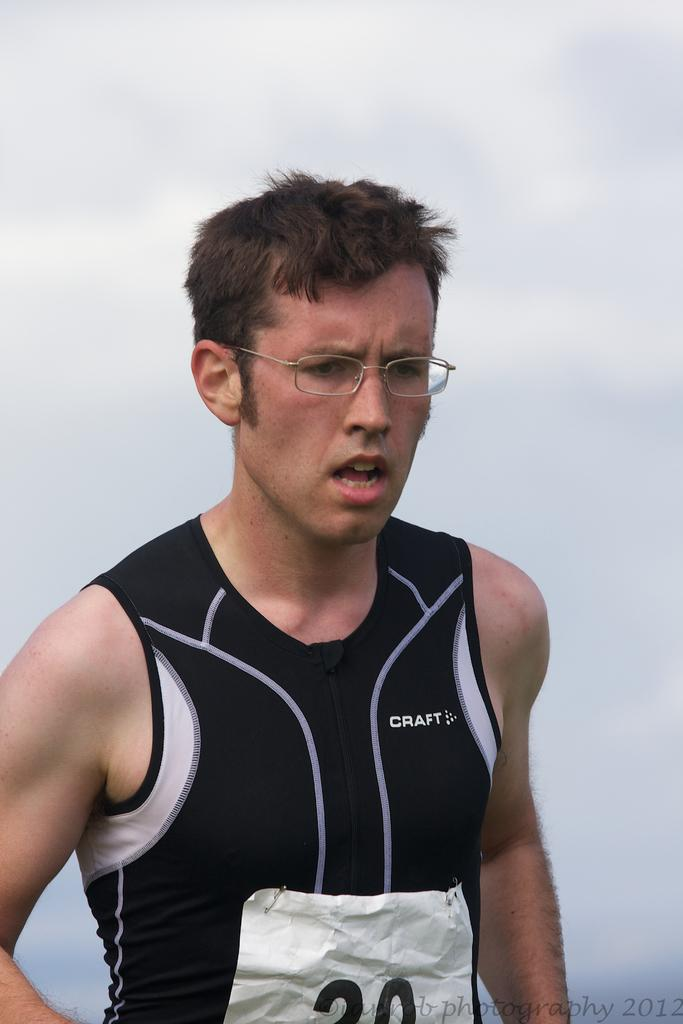Provide a one-sentence caption for the provided image. A race runner wearing a Craft shirt and a number 20 race number. 